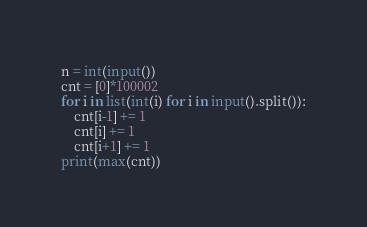<code> <loc_0><loc_0><loc_500><loc_500><_Python_>n = int(input())
cnt = [0]*100002
for i in list(int(i) for i in input().split()):
    cnt[i-1] += 1
    cnt[i] += 1
    cnt[i+1] += 1
print(max(cnt))</code> 